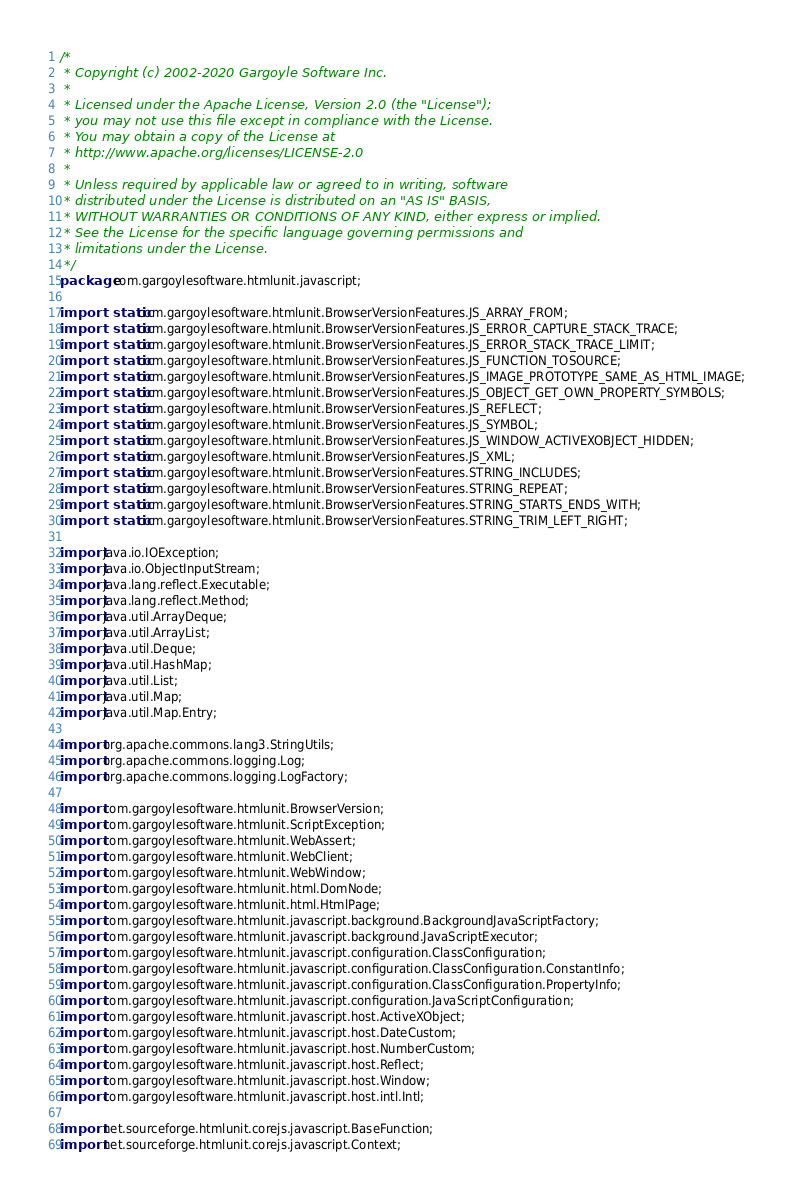Convert code to text. <code><loc_0><loc_0><loc_500><loc_500><_Java_>/*
 * Copyright (c) 2002-2020 Gargoyle Software Inc.
 *
 * Licensed under the Apache License, Version 2.0 (the "License");
 * you may not use this file except in compliance with the License.
 * You may obtain a copy of the License at
 * http://www.apache.org/licenses/LICENSE-2.0
 *
 * Unless required by applicable law or agreed to in writing, software
 * distributed under the License is distributed on an "AS IS" BASIS,
 * WITHOUT WARRANTIES OR CONDITIONS OF ANY KIND, either express or implied.
 * See the License for the specific language governing permissions and
 * limitations under the License.
 */
package com.gargoylesoftware.htmlunit.javascript;

import static com.gargoylesoftware.htmlunit.BrowserVersionFeatures.JS_ARRAY_FROM;
import static com.gargoylesoftware.htmlunit.BrowserVersionFeatures.JS_ERROR_CAPTURE_STACK_TRACE;
import static com.gargoylesoftware.htmlunit.BrowserVersionFeatures.JS_ERROR_STACK_TRACE_LIMIT;
import static com.gargoylesoftware.htmlunit.BrowserVersionFeatures.JS_FUNCTION_TOSOURCE;
import static com.gargoylesoftware.htmlunit.BrowserVersionFeatures.JS_IMAGE_PROTOTYPE_SAME_AS_HTML_IMAGE;
import static com.gargoylesoftware.htmlunit.BrowserVersionFeatures.JS_OBJECT_GET_OWN_PROPERTY_SYMBOLS;
import static com.gargoylesoftware.htmlunit.BrowserVersionFeatures.JS_REFLECT;
import static com.gargoylesoftware.htmlunit.BrowserVersionFeatures.JS_SYMBOL;
import static com.gargoylesoftware.htmlunit.BrowserVersionFeatures.JS_WINDOW_ACTIVEXOBJECT_HIDDEN;
import static com.gargoylesoftware.htmlunit.BrowserVersionFeatures.JS_XML;
import static com.gargoylesoftware.htmlunit.BrowserVersionFeatures.STRING_INCLUDES;
import static com.gargoylesoftware.htmlunit.BrowserVersionFeatures.STRING_REPEAT;
import static com.gargoylesoftware.htmlunit.BrowserVersionFeatures.STRING_STARTS_ENDS_WITH;
import static com.gargoylesoftware.htmlunit.BrowserVersionFeatures.STRING_TRIM_LEFT_RIGHT;

import java.io.IOException;
import java.io.ObjectInputStream;
import java.lang.reflect.Executable;
import java.lang.reflect.Method;
import java.util.ArrayDeque;
import java.util.ArrayList;
import java.util.Deque;
import java.util.HashMap;
import java.util.List;
import java.util.Map;
import java.util.Map.Entry;

import org.apache.commons.lang3.StringUtils;
import org.apache.commons.logging.Log;
import org.apache.commons.logging.LogFactory;

import com.gargoylesoftware.htmlunit.BrowserVersion;
import com.gargoylesoftware.htmlunit.ScriptException;
import com.gargoylesoftware.htmlunit.WebAssert;
import com.gargoylesoftware.htmlunit.WebClient;
import com.gargoylesoftware.htmlunit.WebWindow;
import com.gargoylesoftware.htmlunit.html.DomNode;
import com.gargoylesoftware.htmlunit.html.HtmlPage;
import com.gargoylesoftware.htmlunit.javascript.background.BackgroundJavaScriptFactory;
import com.gargoylesoftware.htmlunit.javascript.background.JavaScriptExecutor;
import com.gargoylesoftware.htmlunit.javascript.configuration.ClassConfiguration;
import com.gargoylesoftware.htmlunit.javascript.configuration.ClassConfiguration.ConstantInfo;
import com.gargoylesoftware.htmlunit.javascript.configuration.ClassConfiguration.PropertyInfo;
import com.gargoylesoftware.htmlunit.javascript.configuration.JavaScriptConfiguration;
import com.gargoylesoftware.htmlunit.javascript.host.ActiveXObject;
import com.gargoylesoftware.htmlunit.javascript.host.DateCustom;
import com.gargoylesoftware.htmlunit.javascript.host.NumberCustom;
import com.gargoylesoftware.htmlunit.javascript.host.Reflect;
import com.gargoylesoftware.htmlunit.javascript.host.Window;
import com.gargoylesoftware.htmlunit.javascript.host.intl.Intl;

import net.sourceforge.htmlunit.corejs.javascript.BaseFunction;
import net.sourceforge.htmlunit.corejs.javascript.Context;</code> 